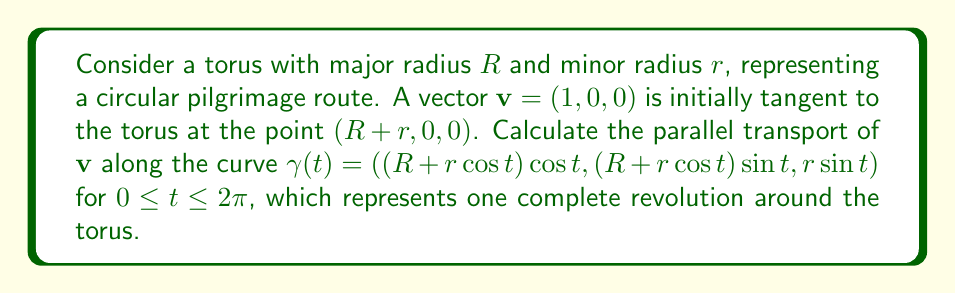Teach me how to tackle this problem. To solve this problem, we'll follow these steps:

1) First, we need to calculate the tangent vector to the curve $\gamma(t)$:
   $$\mathbf{T}(t) = \gamma'(t) = (-(R+r\cos t)\sin t - r\sin t\cos t, (R+r\cos t)\cos t - r\sin t\sin t, r\cos t)$$

2) Next, we calculate the normal vector to the torus surface:
   $$\mathbf{N}(t) = (\cos t\cos t, \cos t\sin t, \sin t)$$

3) The binormal vector is then:
   $$\mathbf{B}(t) = \mathbf{T}(t) \times \mathbf{N}(t)$$

4) For parallel transport, we need to solve the equation:
   $$\frac{d\mathbf{v}}{dt} + \Gamma(\mathbf{T}, \mathbf{v}) = 0$$
   where $\Gamma$ is the connection coefficient.

5) On a torus, the connection coefficient can be expressed as:
   $$\Gamma(\mathbf{T}, \mathbf{v}) = \frac{r\sin t}{R + r\cos t}(\mathbf{v} \cdot \mathbf{B})\mathbf{N}$$

6) Solving this differential equation, we get:
   $$\mathbf{v}(t) = \cos(\phi(t))\mathbf{T}(t) + \sin(\phi(t))\mathbf{B}(t)$$
   where $\phi(t) = \int_0^t \frac{r\sin s}{R + r\cos s} ds$

7) After one complete revolution ($t = 2\pi$), the angle of rotation is:
   $$\phi(2\pi) = \int_0^{2\pi} \frac{r\sin s}{R + r\cos s} ds = 2\pi\left(1 - \frac{R}{\sqrt{R^2 - r^2}}\right)$$

8) Therefore, the final vector after parallel transport is:
   $$\mathbf{v}(2\pi) = \cos\left(2\pi\left(1 - \frac{R}{\sqrt{R^2 - r^2}}\right)\right)(1, 0, 0) + \sin\left(2\pi\left(1 - \frac{R}{\sqrt{R^2 - r^2}}\right)\right)(0, 1, 0)$$
Answer: $\left(\cos\left(2\pi\left(1 - \frac{R}{\sqrt{R^2 - r^2}}\right)\right), \sin\left(2\pi\left(1 - \frac{R}{\sqrt{R^2 - r^2}}\right)\right), 0\right)$ 